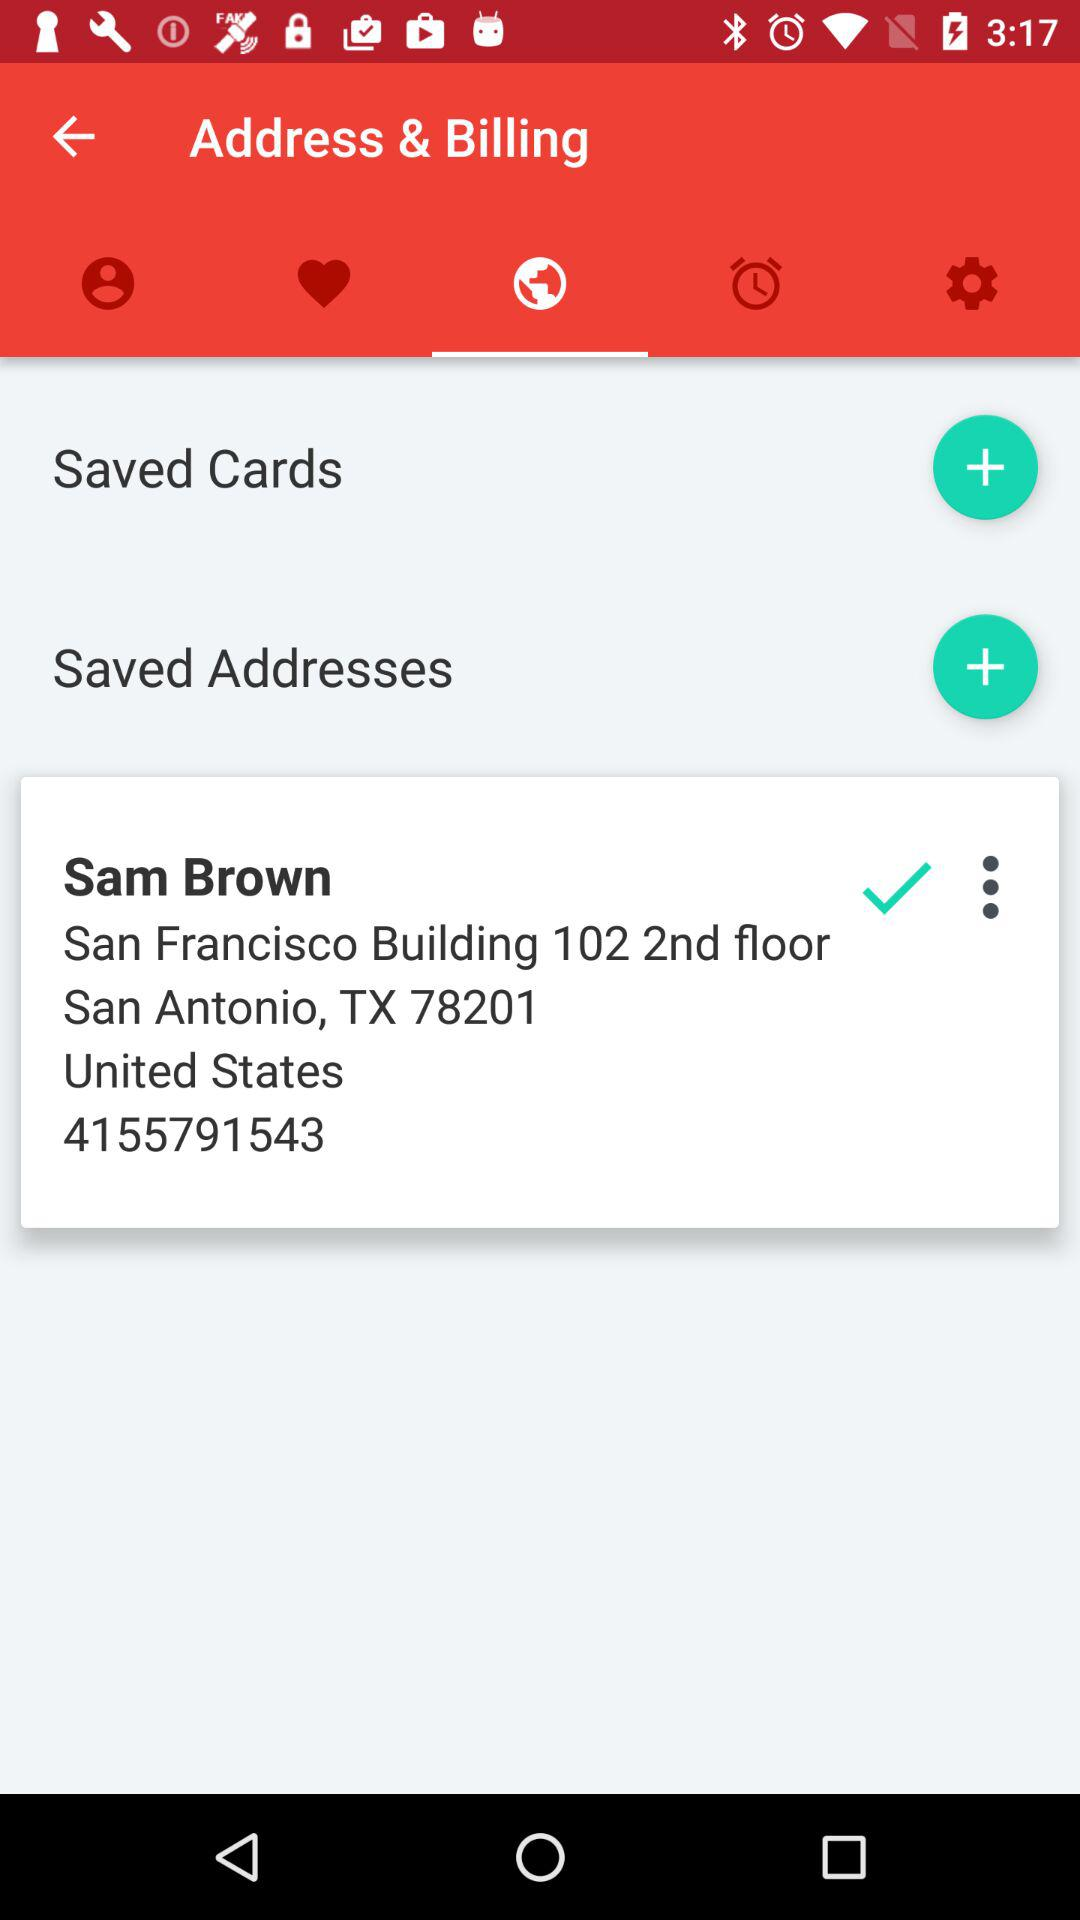How many more Saved Addresses are there than Saved Cards?
Answer the question using a single word or phrase. 1 